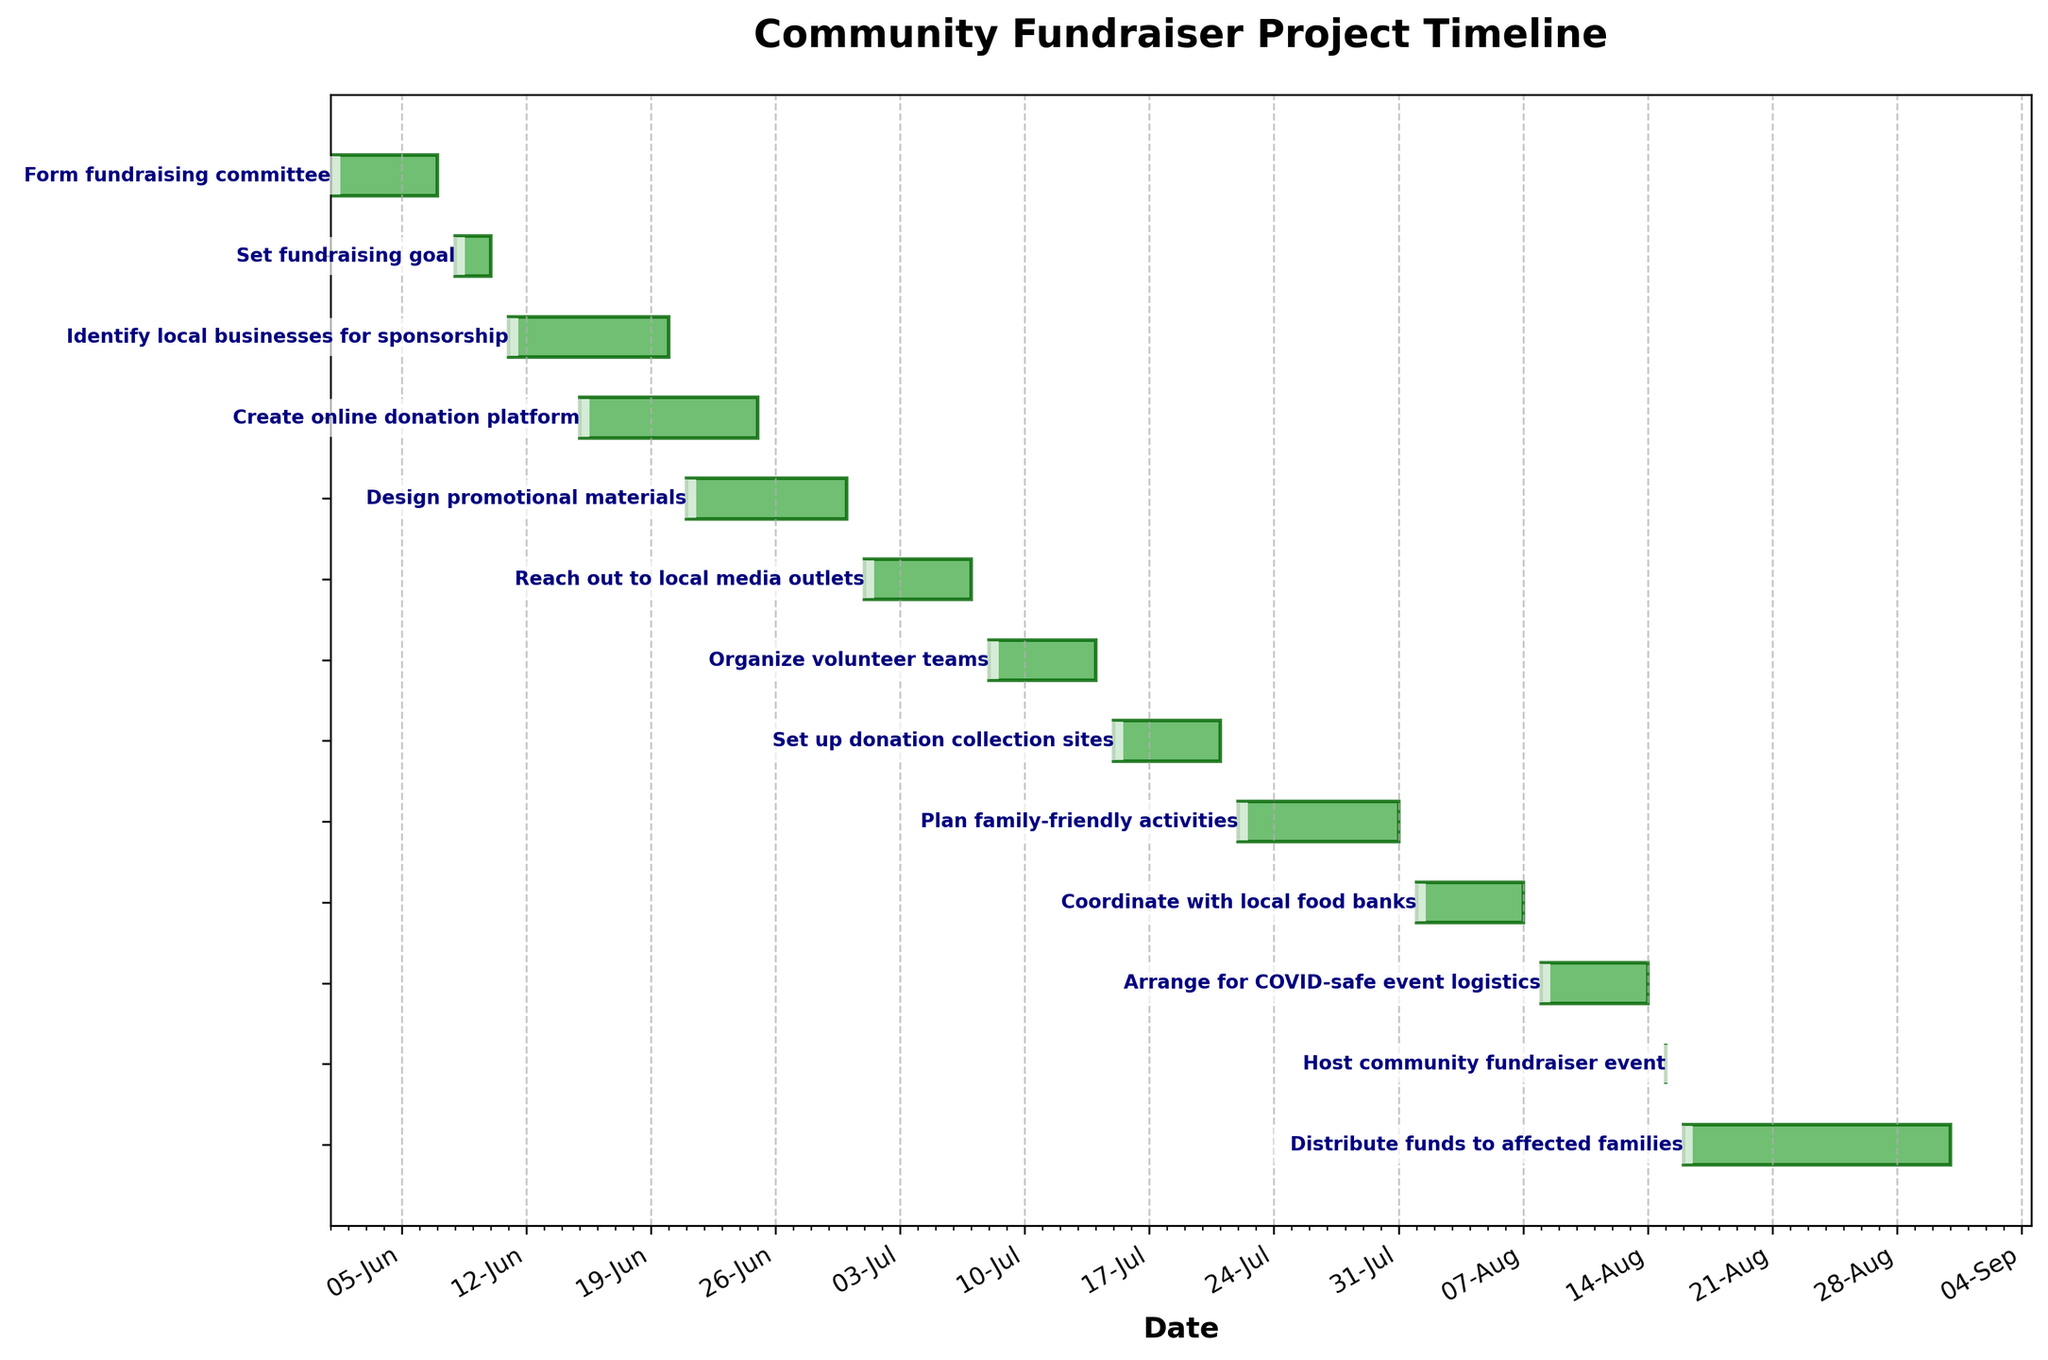What is the title of the Gantt Chart? The title of the Gantt Chart is found at the top of the figure, typically in larger, bold text. In this case, the title is "Community Fundraiser Project Timeline".
Answer: Community Fundraiser Project Timeline What is the duration of the "Identify local businesses for sponsorship" task? We look at the horizontal bar for the task "Identify local businesses for sponsorship" and measure the time period from the start date (June 11) to the end date (June 20). This period includes 10 days.
Answer: 10 days Which task has the longest duration? To determine the task with the longest duration, we compare the lengths of all the bars horizontally. The "Distribute funds to affected families" task has the longest bar, indicating it is the longest task.
Answer: Distribute funds to affected families When does the "Create online donation platform" task end? The end date for the task is labeled at the edge of its corresponding bar. For the "Create online donation platform" task, it ends on June 25.
Answer: June 25 Which task starts right after "Set fundraising goal"? Look at the end date of "Set fundraising goal", which is June 10. The next task to start right after this is "Identify local businesses for sponsorship", which starts on June 11.
Answer: Identify local businesses for sponsorship How many tasks start in July? We filter the tasks by their start dates and count those that fall within July. They are "Reach out to local media outlets", "Organize volunteer teams", "Set up donation collection sites", and "Plan family-friendly activities" — four tasks in total.
Answer: 4 Compare the duration of "Plan family-friendly activities" and "Coordinate with local food banks". Which one is longer? Check the durations of both tasks. "Plan family-friendly activities" (10 days) and "Coordinate with local food banks" (7 days). The first one, "Plan family-friendly activities", is longer.
Answer: Plan family-friendly activities What is the overall timeline for the entire community fundraiser project? The overall timeline spans from the start date of the first task (June 1) to the end date of the last task (August 31).
Answer: June 1 to August 31 Which tasks have the same duration? We compare the durations of all tasks. The tasks "Form fundraising committee", "Reach out to local media outlets", "Organize volunteer teams", "Set up donation collection sites", "Coordinate with local food banks", and "Arrange for COVID-safe event logistics" each have durations of 7 days.
Answer: Form fundraising committee, Reach out to local media outlets, Organize volunteer teams, Set up donation collection sites, Coordinate with local food banks, Arrange for COVID-safe event logistics How long after the "Host community fundraiser event" is the "Distribute funds to affected families" task scheduled to start? The community fundraiser event is on August 15, and the next task starts the day after, on August 16, making it 1 day later.
Answer: 1 day 